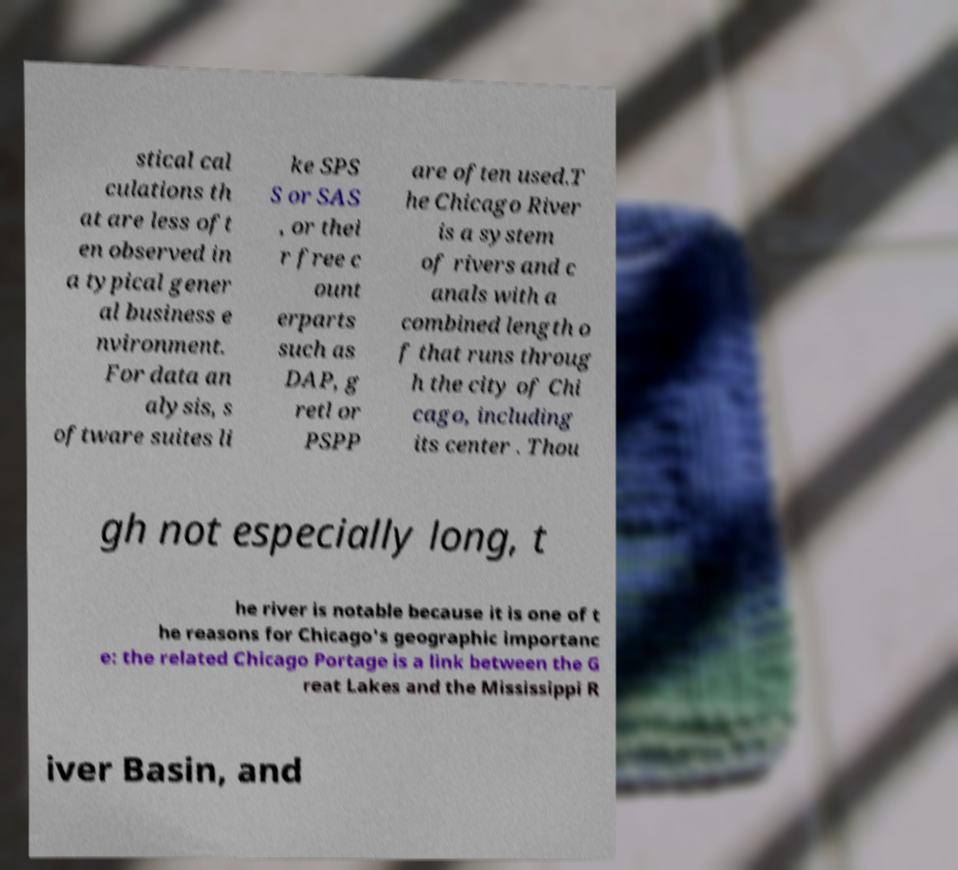Can you read and provide the text displayed in the image?This photo seems to have some interesting text. Can you extract and type it out for me? stical cal culations th at are less oft en observed in a typical gener al business e nvironment. For data an alysis, s oftware suites li ke SPS S or SAS , or thei r free c ount erparts such as DAP, g retl or PSPP are often used.T he Chicago River is a system of rivers and c anals with a combined length o f that runs throug h the city of Chi cago, including its center . Thou gh not especially long, t he river is notable because it is one of t he reasons for Chicago's geographic importanc e: the related Chicago Portage is a link between the G reat Lakes and the Mississippi R iver Basin, and 